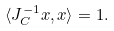<formula> <loc_0><loc_0><loc_500><loc_500>\langle J ^ { - 1 } _ { C } x , x \rangle = 1 .</formula> 